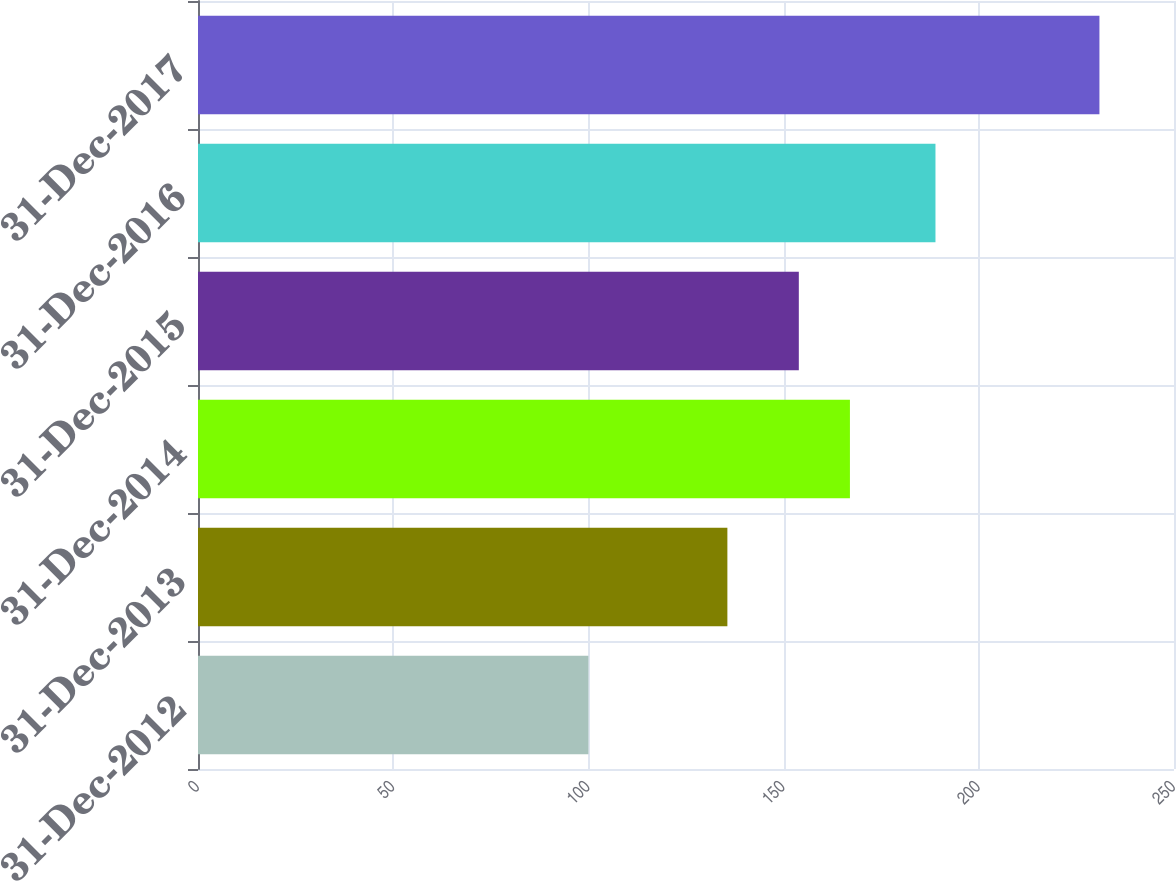Convert chart to OTSL. <chart><loc_0><loc_0><loc_500><loc_500><bar_chart><fcel>31-Dec-2012<fcel>31-Dec-2013<fcel>31-Dec-2014<fcel>31-Dec-2015<fcel>31-Dec-2016<fcel>31-Dec-2017<nl><fcel>100<fcel>135.6<fcel>166.99<fcel>153.9<fcel>188.9<fcel>230.9<nl></chart> 